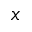<formula> <loc_0><loc_0><loc_500><loc_500>x</formula> 